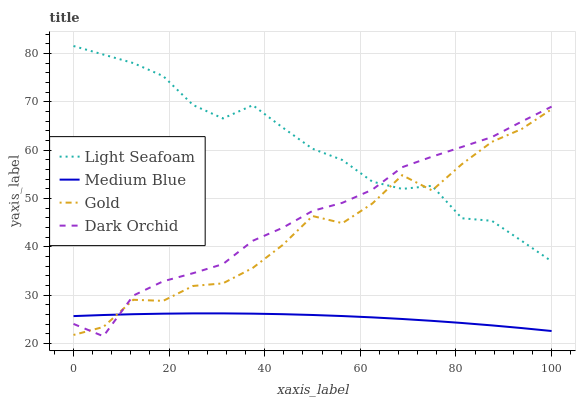Does Medium Blue have the minimum area under the curve?
Answer yes or no. Yes. Does Light Seafoam have the maximum area under the curve?
Answer yes or no. Yes. Does Dark Orchid have the minimum area under the curve?
Answer yes or no. No. Does Dark Orchid have the maximum area under the curve?
Answer yes or no. No. Is Medium Blue the smoothest?
Answer yes or no. Yes. Is Gold the roughest?
Answer yes or no. Yes. Is Dark Orchid the smoothest?
Answer yes or no. No. Is Dark Orchid the roughest?
Answer yes or no. No. Does Dark Orchid have the lowest value?
Answer yes or no. Yes. Does Medium Blue have the lowest value?
Answer yes or no. No. Does Light Seafoam have the highest value?
Answer yes or no. Yes. Does Dark Orchid have the highest value?
Answer yes or no. No. Is Medium Blue less than Light Seafoam?
Answer yes or no. Yes. Is Light Seafoam greater than Medium Blue?
Answer yes or no. Yes. Does Dark Orchid intersect Gold?
Answer yes or no. Yes. Is Dark Orchid less than Gold?
Answer yes or no. No. Is Dark Orchid greater than Gold?
Answer yes or no. No. Does Medium Blue intersect Light Seafoam?
Answer yes or no. No. 